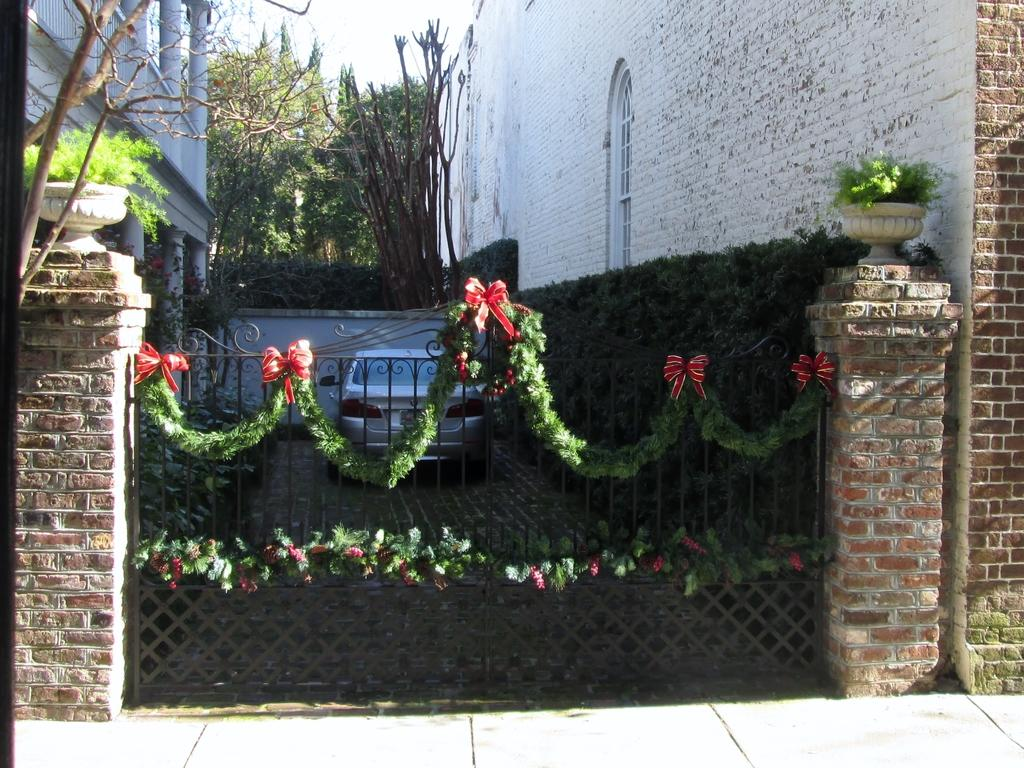What material are the buildings in the image made of? The buildings in the image are made of brick. What can be seen at the entrance of the buildings? There is a gate in the image. What mode of transportation can be seen in the image? A vehicle is visible in the image. What type of container for plants is present in the image? There is a plant pot in the image. What type of vegetation is present in the image? Trees are present in the image. What type of path is visible in the image? There is a footpath in the image. What part of the natural environment is visible in the image? The sky is visible in the image. Where is the bomb located in the image? There is no bomb present in the image. How can you help the plantation in the image? There is no plantation present in the image, so it is not possible to help it. 